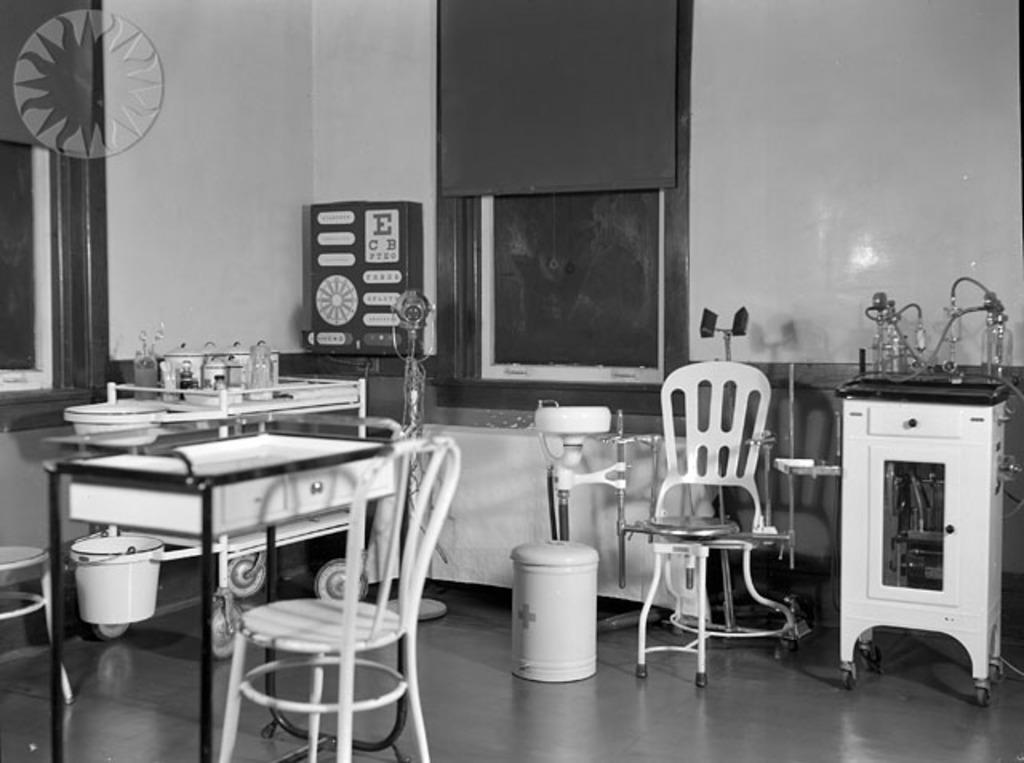What type of objects can be seen in the image? There are trolleys, tables, stands, a dustbin, and a bucket in the image. What type of establishment might this image be depicting? The presence of hospital equipment suggests that this image might be from a hospital or medical facility. What architectural features are visible in the image? There is a wall and windows in the image. Absurd Question/Answer: Can you see an airplane flying outside the windows in the image? No, there is no airplane visible in the image. Is there a sandy beach visible through the windows? No, there is no sandy beach visible through the windows; the windows show the view of the hospital or medical facility. 